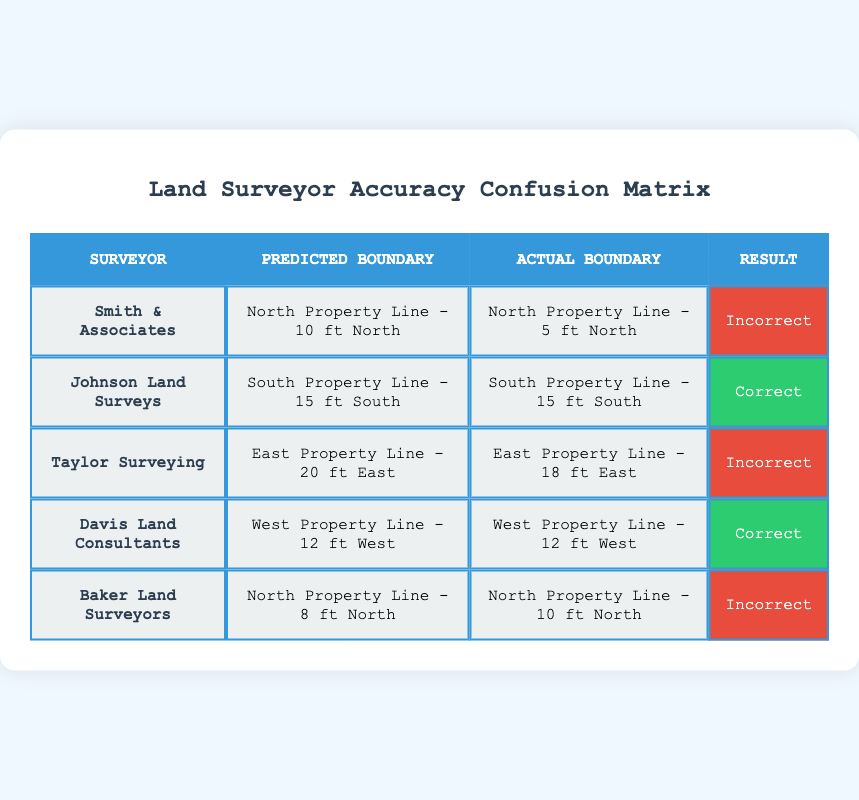What are the names of the surveyors who provided correct boundary predictions? Review the "Result" column for the entries marked as "Correct." The surveyors listed with correct predictions are Johnson Land Surveys and Davis Land Consultants.
Answer: Johnson Land Surveys, Davis Land Consultants How many surveyors made incorrect boundary predictions? Count the entries in the "Result" column marked as "Incorrect." There are three such entries: Smith & Associates, Taylor Surveying, and Baker Land Surveyors.
Answer: 3 What was the predicted boundary for Taylor Surveying? Look for the row pertaining to Taylor Surveying in the table, which shows their predicted boundary as "East Property Line - 20 ft East."
Answer: East Property Line - 20 ft East Is it true that all surveyors predicted their boundaries correctly? Check the "Result" column for any entries marked "Incorrect." There are three surveyors who did not predict correctly, so the statement is false.
Answer: No Which land surveyor had the closest prediction to the actual boundary? Analyze the differences between the predicted and actual boundaries for all surveyors. Only Johnson Land Surveys and Davis Land Consultants had an exact match, while others were incorrect. Therefore, they are the closest to accuracy.
Answer: Johnson Land Surveys, Davis Land Consultants What was the distance error for Baker Land Surveyors’ prediction? Calculate the distance error by taking the predicted boundary "North Property Line - 8 ft North" and comparing it to the actual boundary "North Property Line - 10 ft North." The error is 2 feet south.
Answer: 2 feet How many total predictions were made by all surveyors? Count the total number of entries (rows) in the table, which lists five surveyors. Therefore, the total number of predictions is five.
Answer: 5 What percentage of all surveyed predictions were correct? There are 5 predictions in total. Out of these, 2 predictions were correct. The percentage is calculated as (2 correct / 5 total) * 100 = 40%.
Answer: 40% 